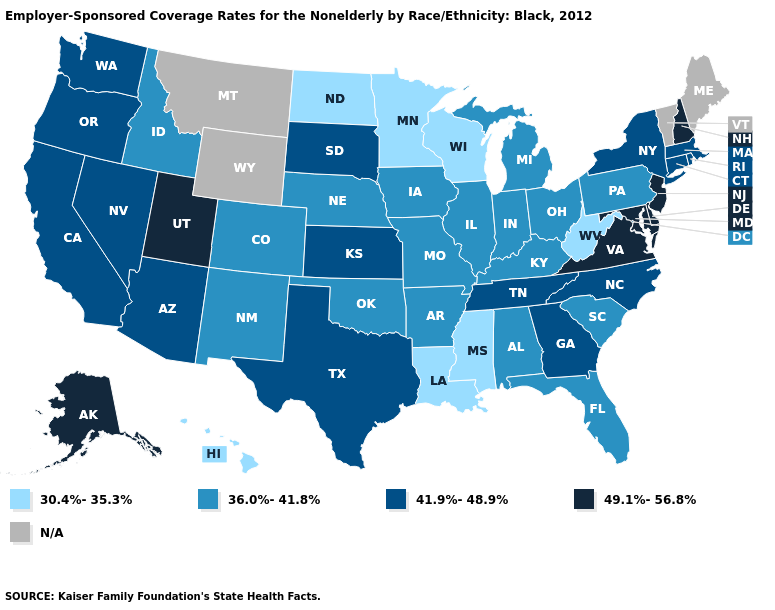Among the states that border Ohio , does West Virginia have the highest value?
Answer briefly. No. Name the states that have a value in the range 30.4%-35.3%?
Short answer required. Hawaii, Louisiana, Minnesota, Mississippi, North Dakota, West Virginia, Wisconsin. Which states hav the highest value in the South?
Write a very short answer. Delaware, Maryland, Virginia. Name the states that have a value in the range 36.0%-41.8%?
Give a very brief answer. Alabama, Arkansas, Colorado, Florida, Idaho, Illinois, Indiana, Iowa, Kentucky, Michigan, Missouri, Nebraska, New Mexico, Ohio, Oklahoma, Pennsylvania, South Carolina. What is the value of Oklahoma?
Keep it brief. 36.0%-41.8%. What is the value of Idaho?
Short answer required. 36.0%-41.8%. What is the value of Arizona?
Concise answer only. 41.9%-48.9%. What is the highest value in the USA?
Write a very short answer. 49.1%-56.8%. What is the lowest value in states that border North Carolina?
Give a very brief answer. 36.0%-41.8%. What is the highest value in states that border Oregon?
Quick response, please. 41.9%-48.9%. What is the value of Mississippi?
Answer briefly. 30.4%-35.3%. Does Wisconsin have the lowest value in the MidWest?
Give a very brief answer. Yes. What is the lowest value in the USA?
Be succinct. 30.4%-35.3%. 